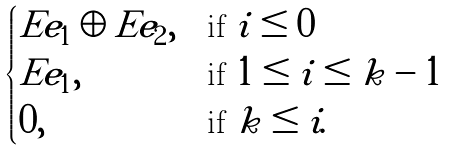<formula> <loc_0><loc_0><loc_500><loc_500>\begin{cases} E e _ { 1 } \oplus E e _ { 2 } , & \text {if } i \leq 0 \\ E e _ { 1 } , & \text {if } 1 \leq i \leq k - 1 \\ 0 , & \text {if } k \leq i . \end{cases}</formula> 